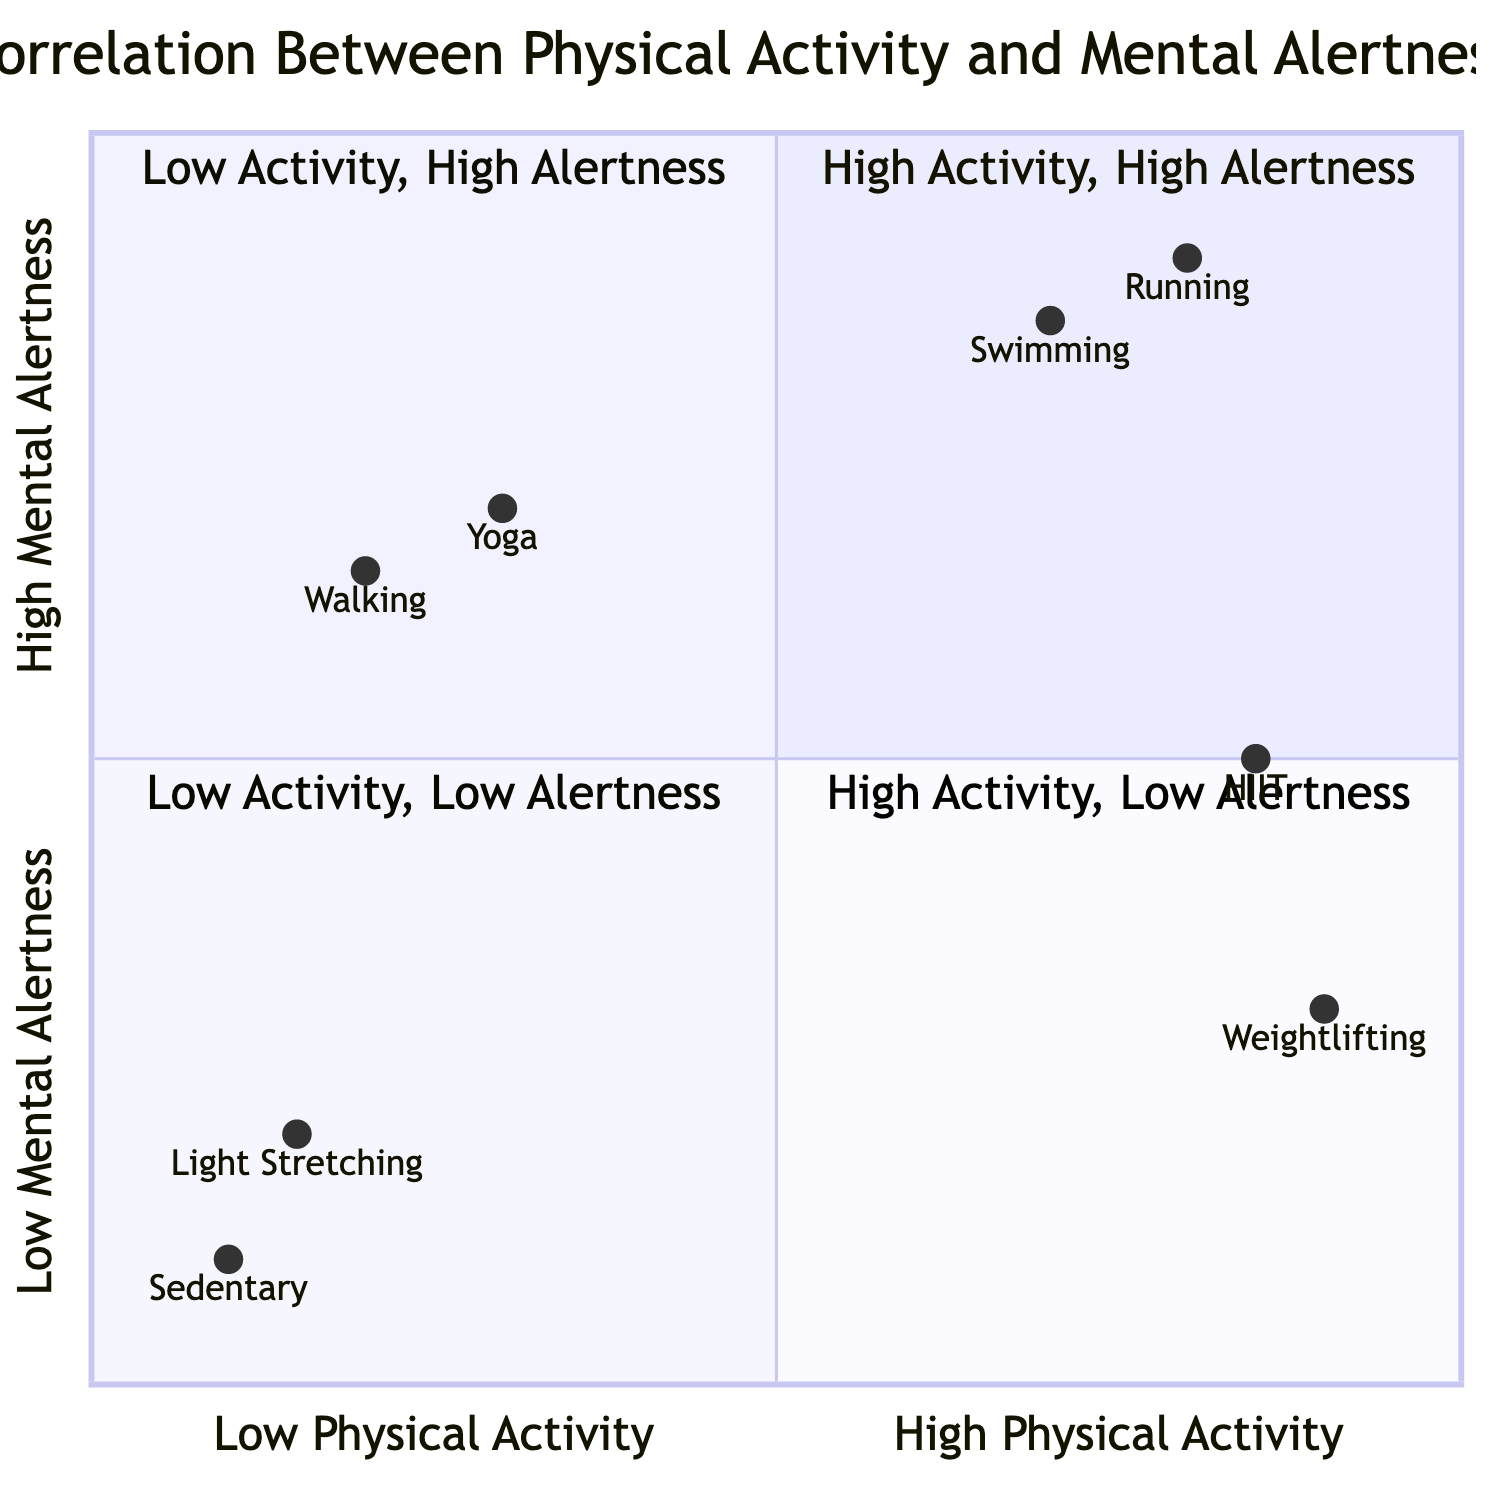What activities are listed in the "High Physical Activity, High Mental Alertness" quadrant? The "High Physical Activity, High Mental Alertness" quadrant includes "Running" and "Swimming" as the activities identified in this section of the diagram.
Answer: Running, Swimming How many examples are there in the "Low Physical Activity, Low Mental Alertness" quadrant? The "Low Physical Activity, Low Mental Alertness" quadrant contains two examples: "Sedentary" and "Light Stretching." Therefore, the total count is 2.
Answer: 2 Which activity has the highest mental alertness level among all examples? The activity with the highest mental alertness level is "Running," noted as having a mental alertness level categorized as "High."
Answer: Running What is the combined frequency of physical activity in the "High Physical Activity, Low Mental Alertness" quadrant? In the "High Physical Activity, Low Mental Alertness" quadrant, the activities are performed with a frequency of 5 times a week for "Weightlifting" and 4 times a week for "HIIT." Thus, the combined frequency is 5 + 4, totaling 9.
Answer: 9 times a week Which quadrant contains activities that are performed daily yet have low mental alertness levels? The "Low Physical Activity, Low Mental Alertness" quadrant contains activities that are performed daily ("Sedentary" for 8 hours and "Light Stretching" for 10 minutes) but results in low mental alertness.
Answer: Low Physical Activity, Low Mental Alertness Which activity in the "Low Physical Activity, High Mental Alertness" quadrant is performed daily? "Yoga" is the activity listed in the "Low Physical Activity, High Mental Alertness" quadrant that is performed daily for a duration of 20 minutes.
Answer: Yoga 